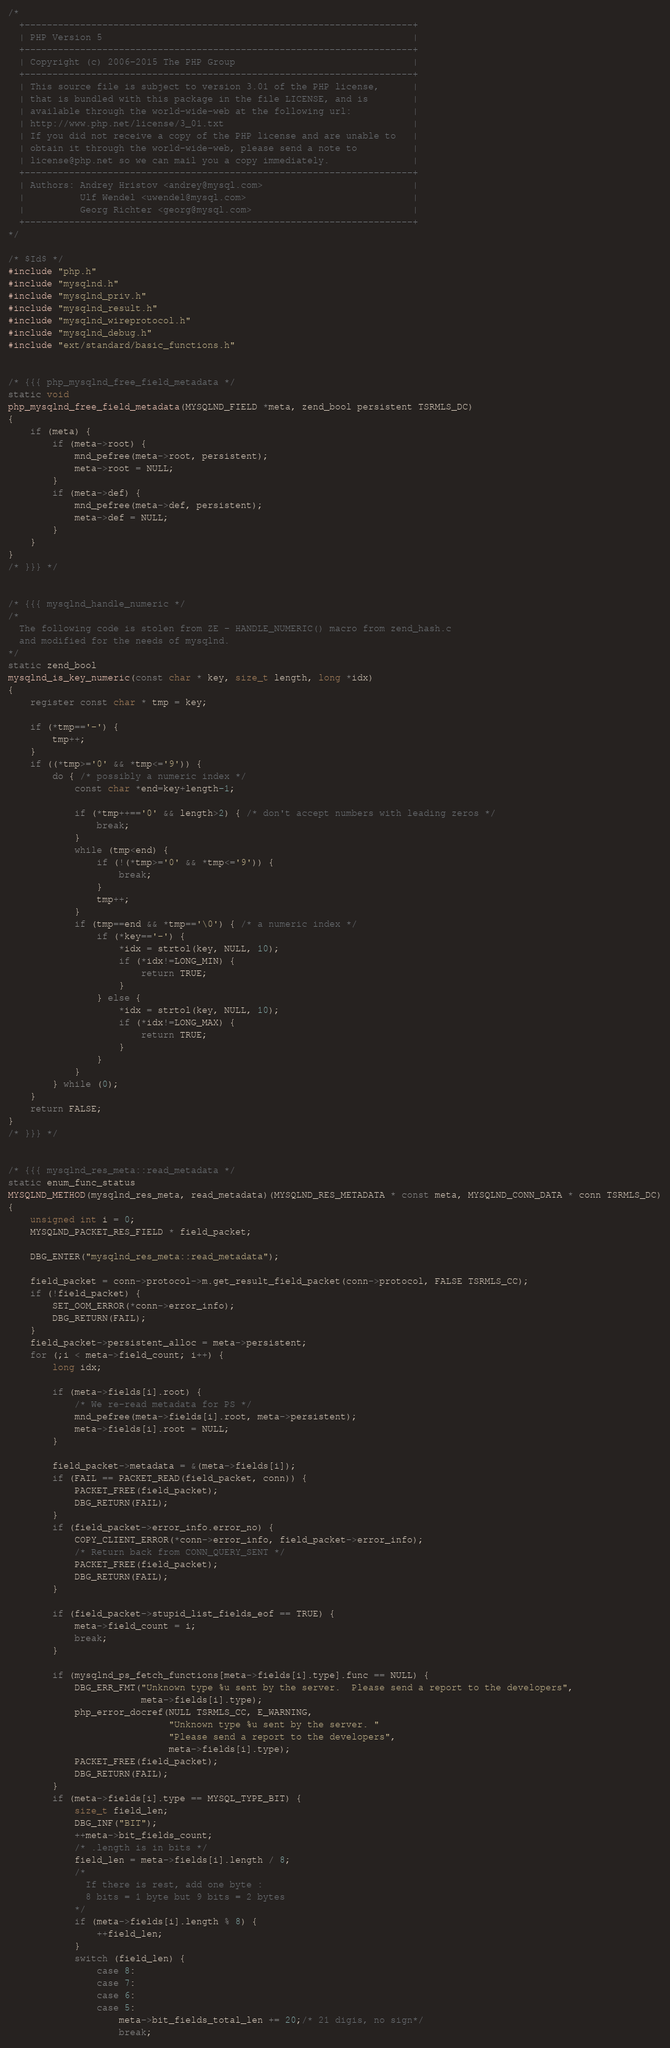<code> <loc_0><loc_0><loc_500><loc_500><_C_>/*
  +----------------------------------------------------------------------+
  | PHP Version 5                                                        |
  +----------------------------------------------------------------------+
  | Copyright (c) 2006-2015 The PHP Group                                |
  +----------------------------------------------------------------------+
  | This source file is subject to version 3.01 of the PHP license,      |
  | that is bundled with this package in the file LICENSE, and is        |
  | available through the world-wide-web at the following url:           |
  | http://www.php.net/license/3_01.txt                                  |
  | If you did not receive a copy of the PHP license and are unable to   |
  | obtain it through the world-wide-web, please send a note to          |
  | license@php.net so we can mail you a copy immediately.               |
  +----------------------------------------------------------------------+
  | Authors: Andrey Hristov <andrey@mysql.com>                           |
  |          Ulf Wendel <uwendel@mysql.com>                              |
  |          Georg Richter <georg@mysql.com>                             |
  +----------------------------------------------------------------------+
*/

/* $Id$ */
#include "php.h"
#include "mysqlnd.h"
#include "mysqlnd_priv.h"
#include "mysqlnd_result.h"
#include "mysqlnd_wireprotocol.h"
#include "mysqlnd_debug.h"
#include "ext/standard/basic_functions.h"


/* {{{ php_mysqlnd_free_field_metadata */
static void
php_mysqlnd_free_field_metadata(MYSQLND_FIELD *meta, zend_bool persistent TSRMLS_DC)
{
	if (meta) {
		if (meta->root) {
			mnd_pefree(meta->root, persistent);
			meta->root = NULL;
		}
		if (meta->def) {
			mnd_pefree(meta->def, persistent);
			meta->def = NULL;
		}
	}
}
/* }}} */


/* {{{ mysqlnd_handle_numeric */
/*
  The following code is stolen from ZE - HANDLE_NUMERIC() macro from zend_hash.c
  and modified for the needs of mysqlnd.
*/
static zend_bool
mysqlnd_is_key_numeric(const char * key, size_t length, long *idx)
{
	register const char * tmp = key;

	if (*tmp=='-') {
		tmp++;
	}
	if ((*tmp>='0' && *tmp<='9')) {
		do { /* possibly a numeric index */
			const char *end=key+length-1;

			if (*tmp++=='0' && length>2) { /* don't accept numbers with leading zeros */
				break;
			}
			while (tmp<end) {
				if (!(*tmp>='0' && *tmp<='9')) {
					break;
				}
				tmp++;
			}
			if (tmp==end && *tmp=='\0') { /* a numeric index */
				if (*key=='-') {
					*idx = strtol(key, NULL, 10);
					if (*idx!=LONG_MIN) {
						return TRUE;
					}
				} else {
					*idx = strtol(key, NULL, 10);
					if (*idx!=LONG_MAX) {
						return TRUE;
					}
				}
			}
		} while (0);
	}
	return FALSE;
}
/* }}} */


/* {{{ mysqlnd_res_meta::read_metadata */
static enum_func_status
MYSQLND_METHOD(mysqlnd_res_meta, read_metadata)(MYSQLND_RES_METADATA * const meta, MYSQLND_CONN_DATA * conn TSRMLS_DC)
{
	unsigned int i = 0;
	MYSQLND_PACKET_RES_FIELD * field_packet;

	DBG_ENTER("mysqlnd_res_meta::read_metadata");

	field_packet = conn->protocol->m.get_result_field_packet(conn->protocol, FALSE TSRMLS_CC);
	if (!field_packet) {
		SET_OOM_ERROR(*conn->error_info);
		DBG_RETURN(FAIL);
	}
	field_packet->persistent_alloc = meta->persistent;
	for (;i < meta->field_count; i++) {
		long idx;

		if (meta->fields[i].root) {
			/* We re-read metadata for PS */
			mnd_pefree(meta->fields[i].root, meta->persistent);
			meta->fields[i].root = NULL;
		}

		field_packet->metadata = &(meta->fields[i]);
		if (FAIL == PACKET_READ(field_packet, conn)) {
			PACKET_FREE(field_packet);
			DBG_RETURN(FAIL);
		}
		if (field_packet->error_info.error_no) {
			COPY_CLIENT_ERROR(*conn->error_info, field_packet->error_info);
			/* Return back from CONN_QUERY_SENT */
			PACKET_FREE(field_packet);
			DBG_RETURN(FAIL);
		}

		if (field_packet->stupid_list_fields_eof == TRUE) {
			meta->field_count = i;
			break;
		}

		if (mysqlnd_ps_fetch_functions[meta->fields[i].type].func == NULL) {
			DBG_ERR_FMT("Unknown type %u sent by the server.  Please send a report to the developers",
						meta->fields[i].type);
			php_error_docref(NULL TSRMLS_CC, E_WARNING,
							 "Unknown type %u sent by the server. "
							 "Please send a report to the developers",
							 meta->fields[i].type);
			PACKET_FREE(field_packet);
			DBG_RETURN(FAIL);
		}
		if (meta->fields[i].type == MYSQL_TYPE_BIT) {
			size_t field_len;
			DBG_INF("BIT");
			++meta->bit_fields_count;
			/* .length is in bits */
			field_len = meta->fields[i].length / 8;
			/*
			  If there is rest, add one byte :
			  8 bits = 1 byte but 9 bits = 2 bytes
			*/
			if (meta->fields[i].length % 8) {
				++field_len;
			}
			switch (field_len) {
				case 8:
				case 7:
				case 6:
				case 5:
					meta->bit_fields_total_len += 20;/* 21 digis, no sign*/
					break;</code> 